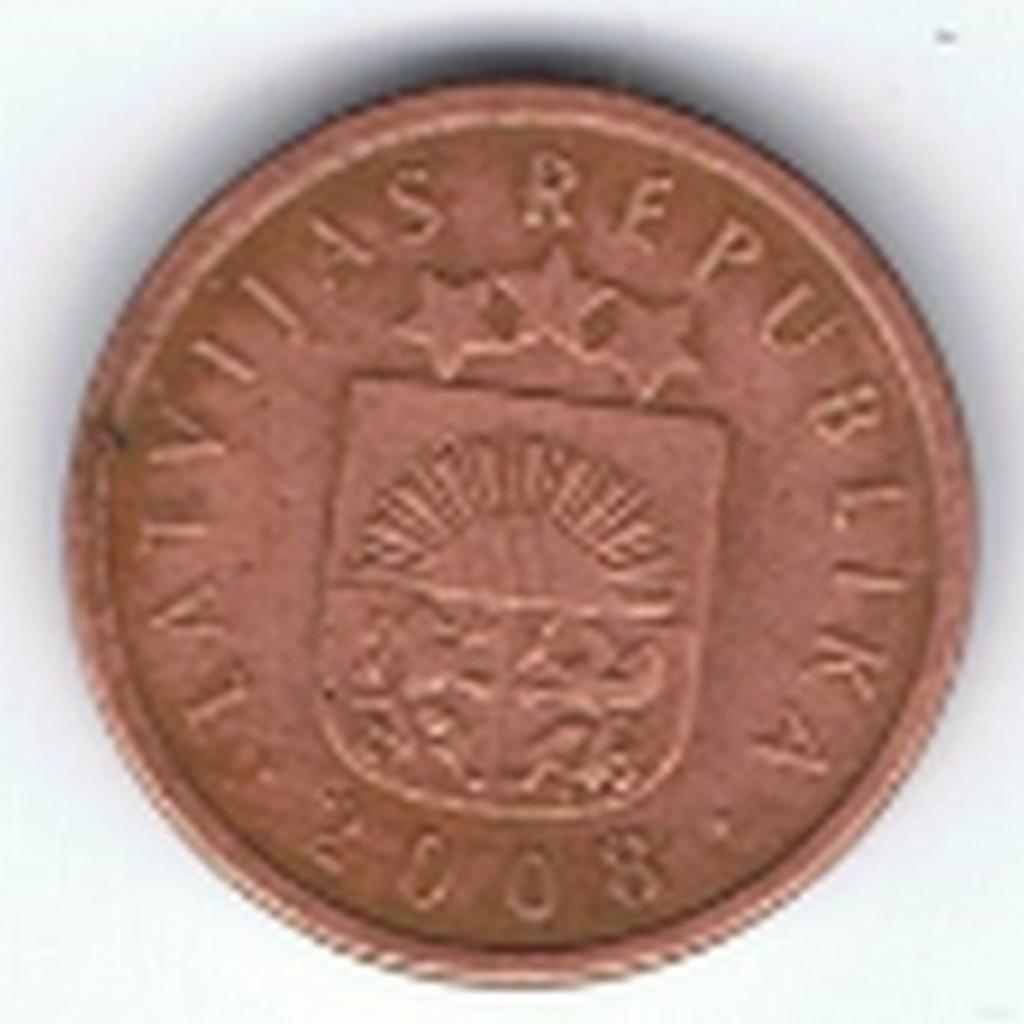Can you describe this image briefly? In the image we can see there is a bronze coin. 